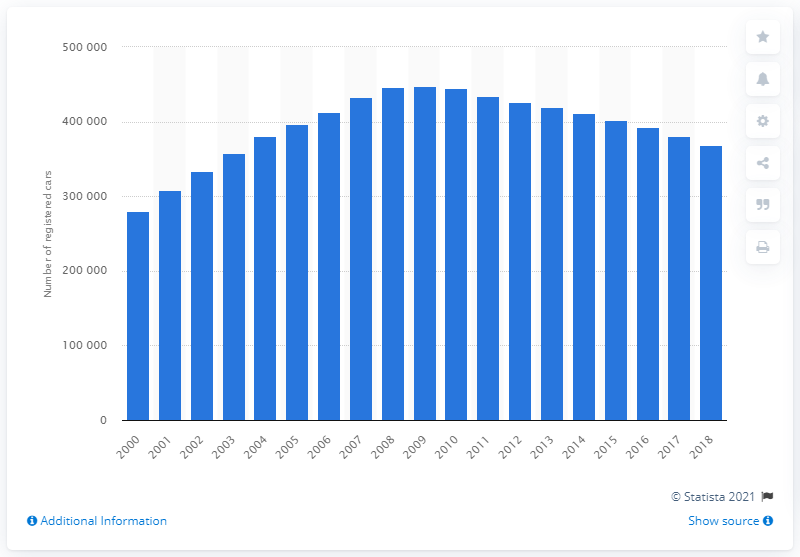Outline some significant characteristics in this image. By the end of 2009, the highest number of cars registered in Great Britain was 444916. The highest number of cars registered in Great Britain by the end of 2009 was 444,916. 